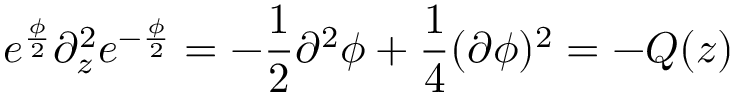<formula> <loc_0><loc_0><loc_500><loc_500>e ^ { \frac { \phi } { 2 } } \partial _ { z } ^ { 2 } e ^ { - \frac { \phi } { 2 } } = - \frac { 1 } { 2 } \partial ^ { 2 } \phi + \frac { 1 } { 4 } ( \partial \phi ) ^ { 2 } = - Q ( z )</formula> 